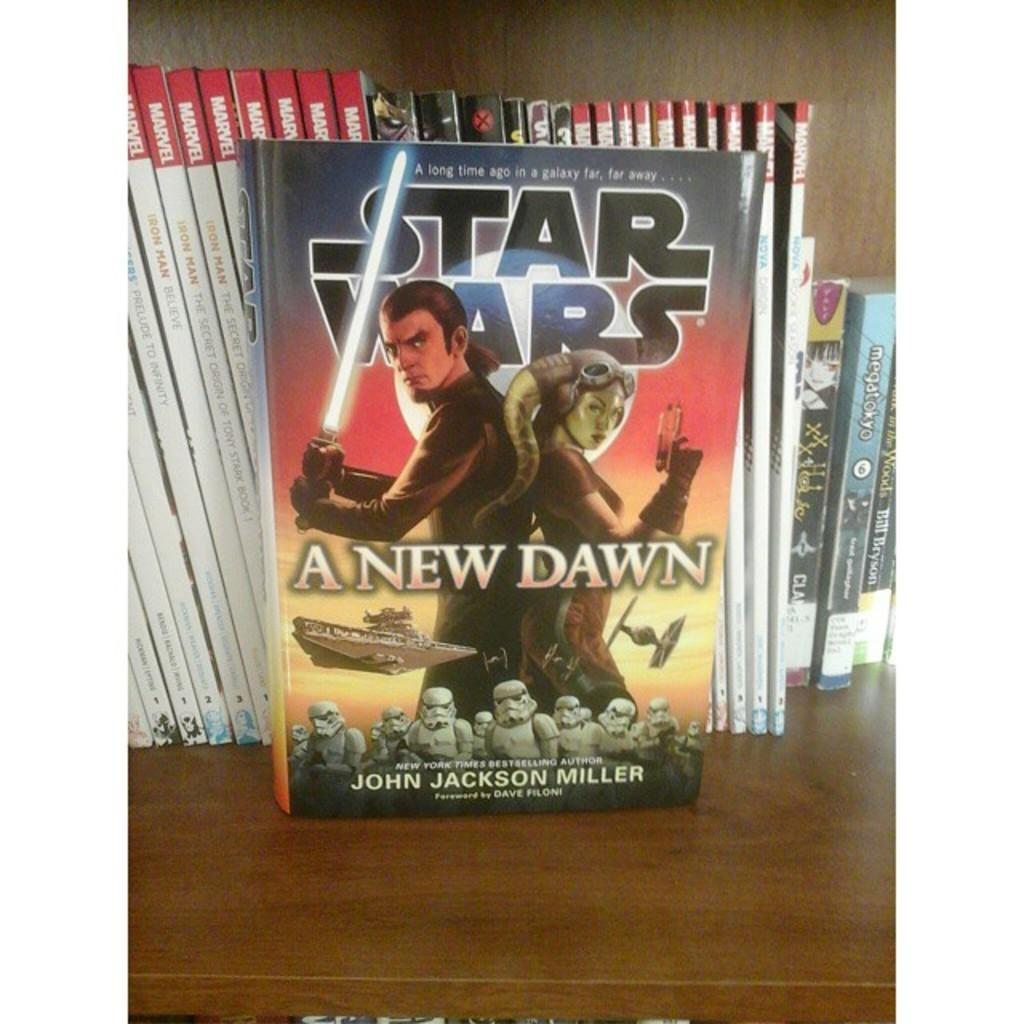<image>
Render a clear and concise summary of the photo. A Star Wars book called A New Dawn sits in front of several Marvel books. 